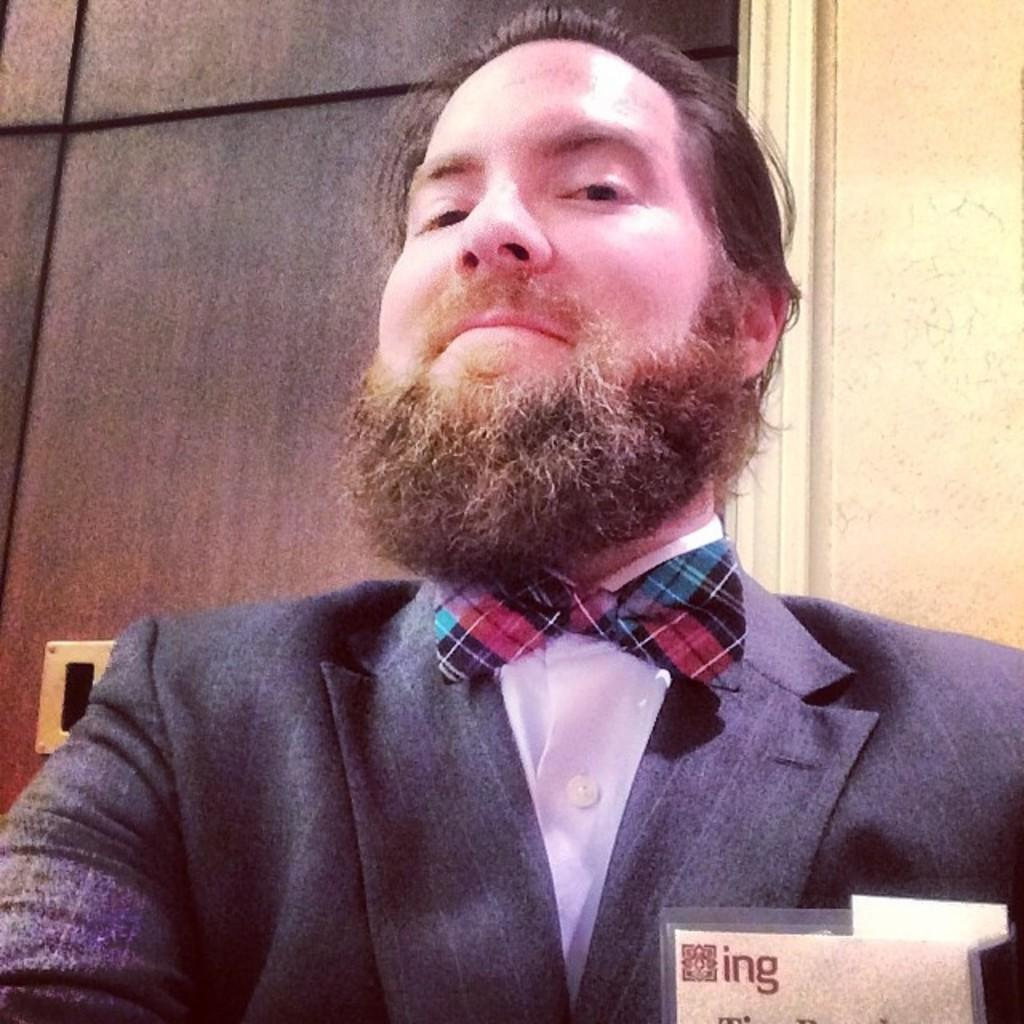Who is present in the image? There is a man in the image. What can be seen in the background of the image? There is a door and a wall in the background of the image. What is located at the bottom of the image? There is a card at the bottom of the image. What religious symbols are present in the image? There are no religious symbols present in the image. How many children are visible in the image? There are no children visible in the image. 